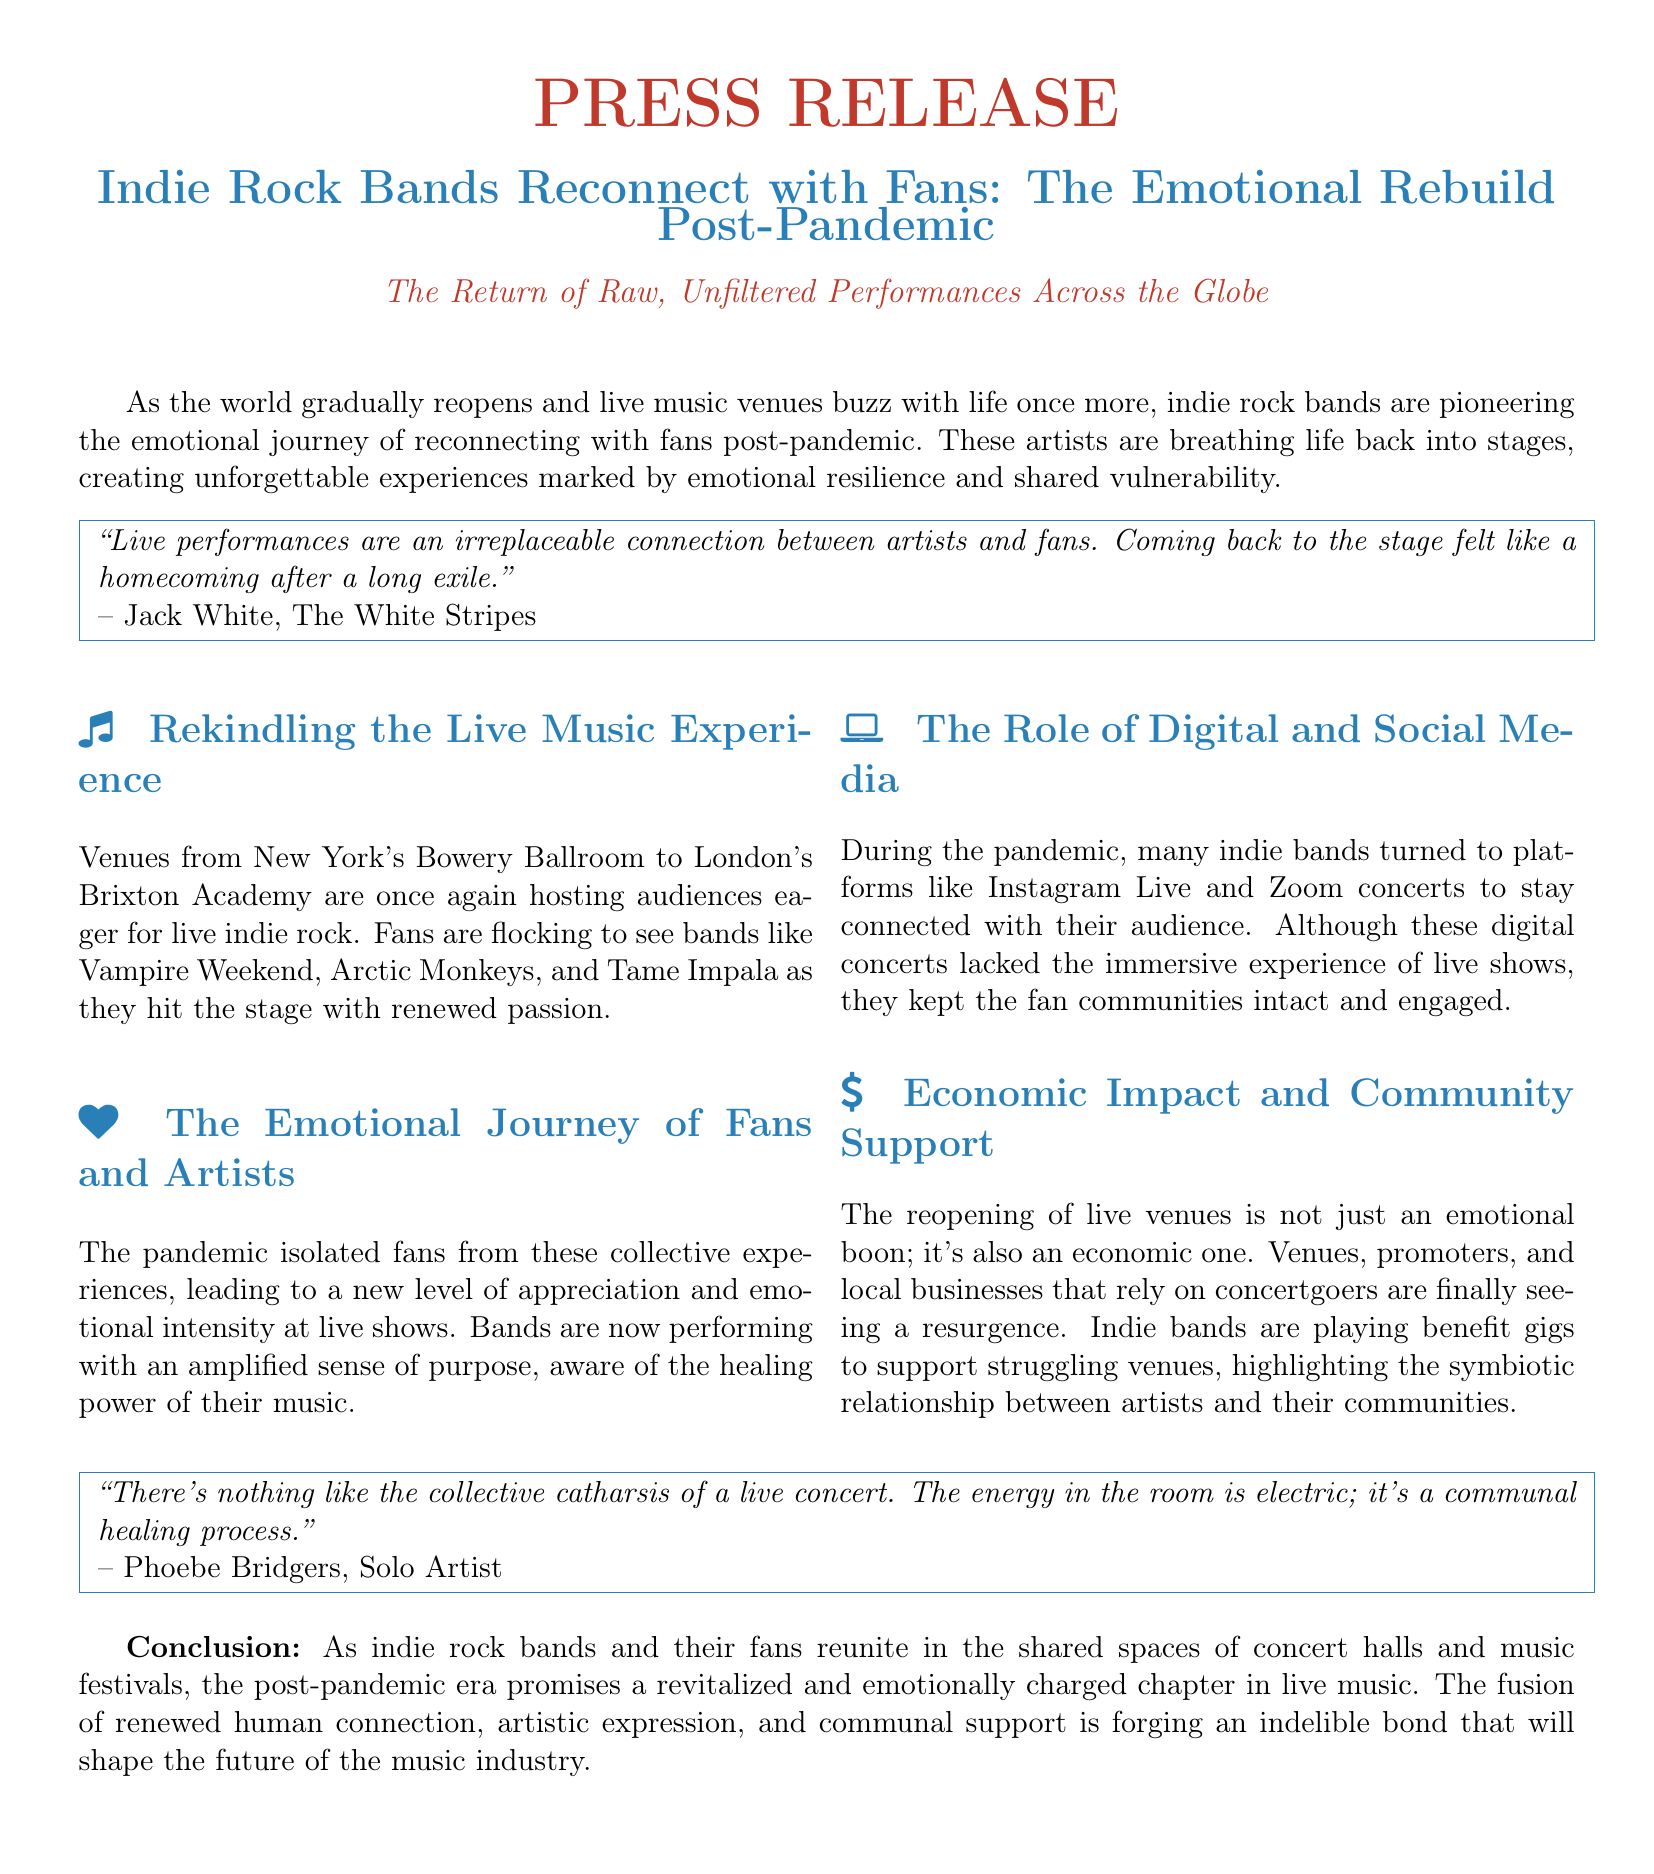what is the title of the press release? The title is explicitly stated in the document, which focuses on indie rock bands reconnecting with fans post-pandemic.
Answer: Indie Rock Bands Reconnect with Fans: The Emotional Rebuild Post-Pandemic who is quoted in the document about the live performances connection? The quote about live performances comes from a well-known musician mentioned in the document, emphasizing the emotional connection felt during performances.
Answer: Jack White, The White Stripes what major indie rock bands are mentioned in the document? The document names several prominent indie rock bands as examples of those performing post-pandemic.
Answer: Vampire Weekend, Arctic Monkeys, and Tame Impala what role did digital platforms play during the pandemic for indie bands? The document discusses the importance of digital platforms for maintaining connections with fans during the pandemic.
Answer: Staying connected how do live performances serve as a communal experience, according to the document? The document describes live concerts as a shared emotional experience that aids in healing for both fans and artists.
Answer: Collective catharsis what is emphasized about the reopening of live venues beyond emotional connections? The document mentions the economic impact of reviving live music venues and related community businesses.
Answer: Economic impact who else is quoted in the document regarding the experience of live concerts? The document includes a quote from another solo artist who reflects on the communal aspect of live performances.
Answer: Phoebe Bridgers, Solo Artist what was the purpose of benefit gigs mentioned in the document? The document states that benefit gigs are aimed at providing support to a specific sector affected by the pandemic.
Answer: Support struggling venues 